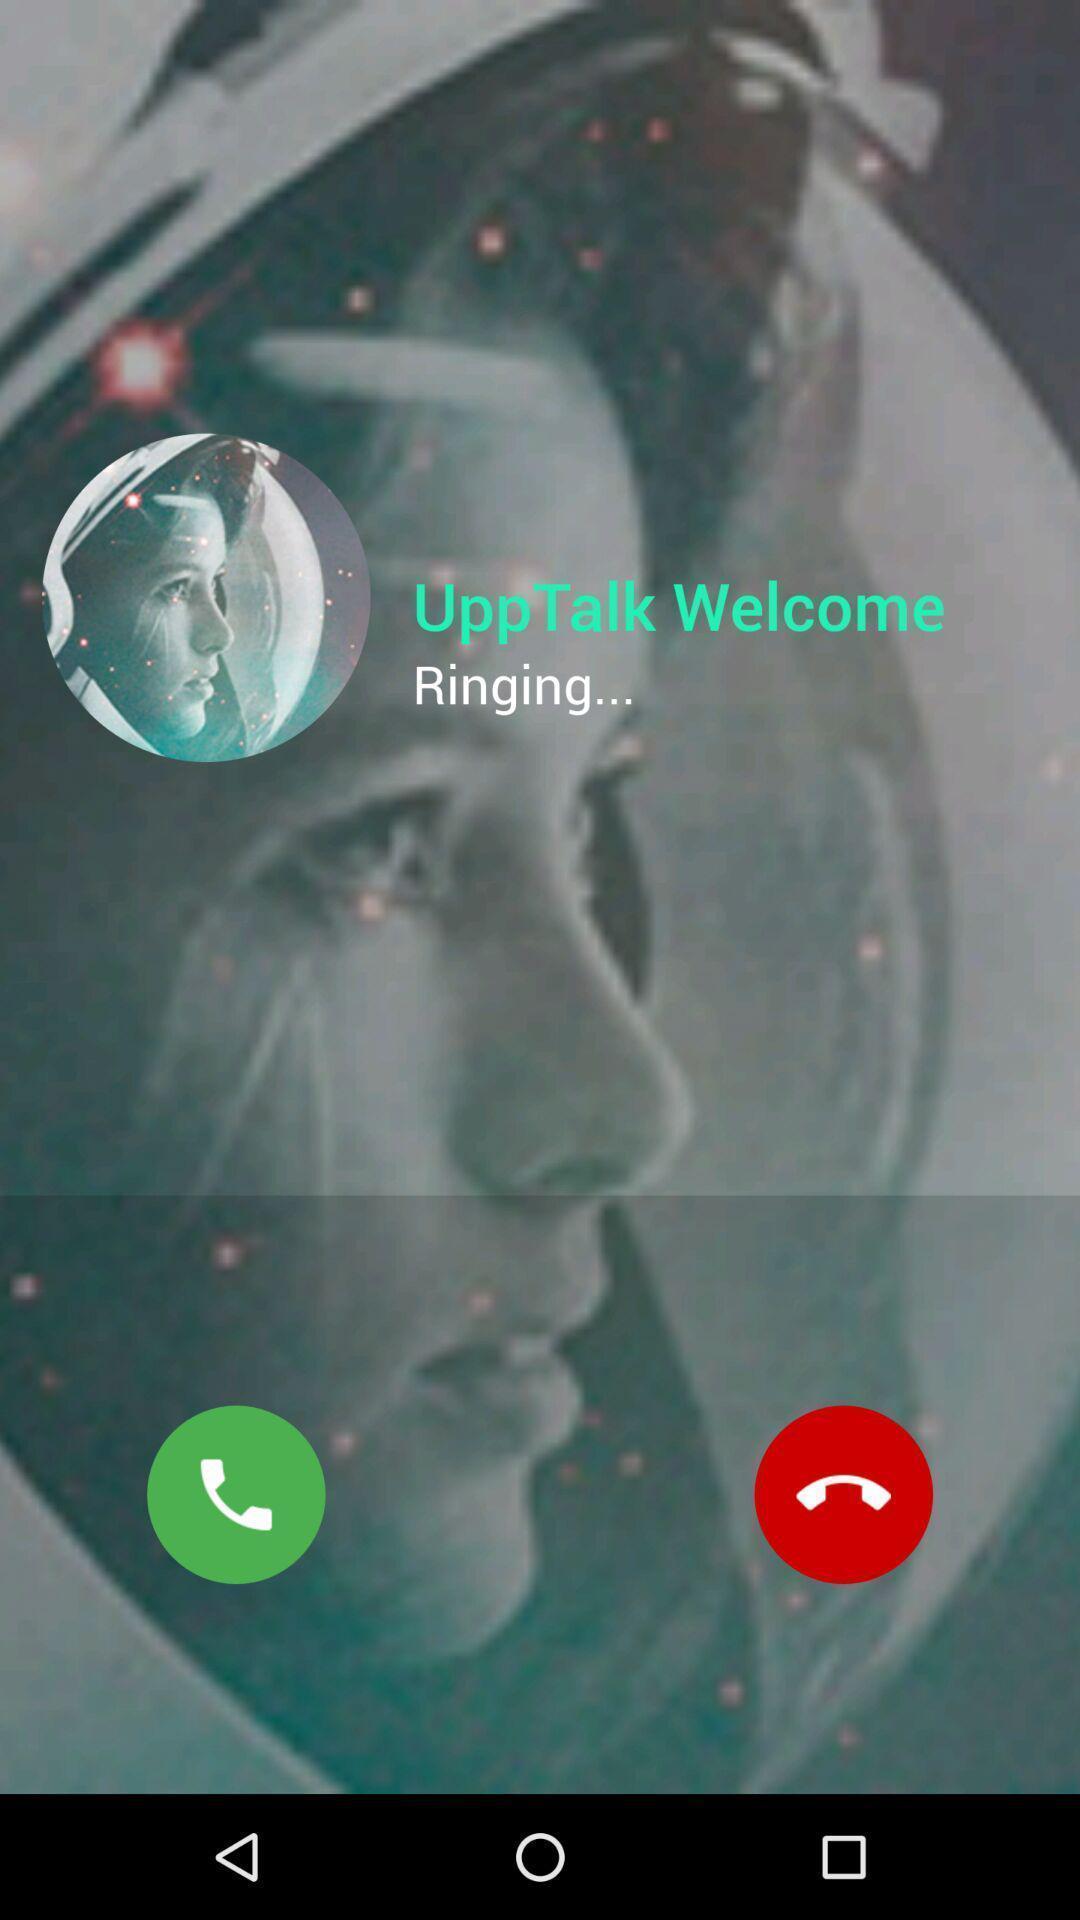Give me a summary of this screen capture. Screen displaying a caller on a device. 